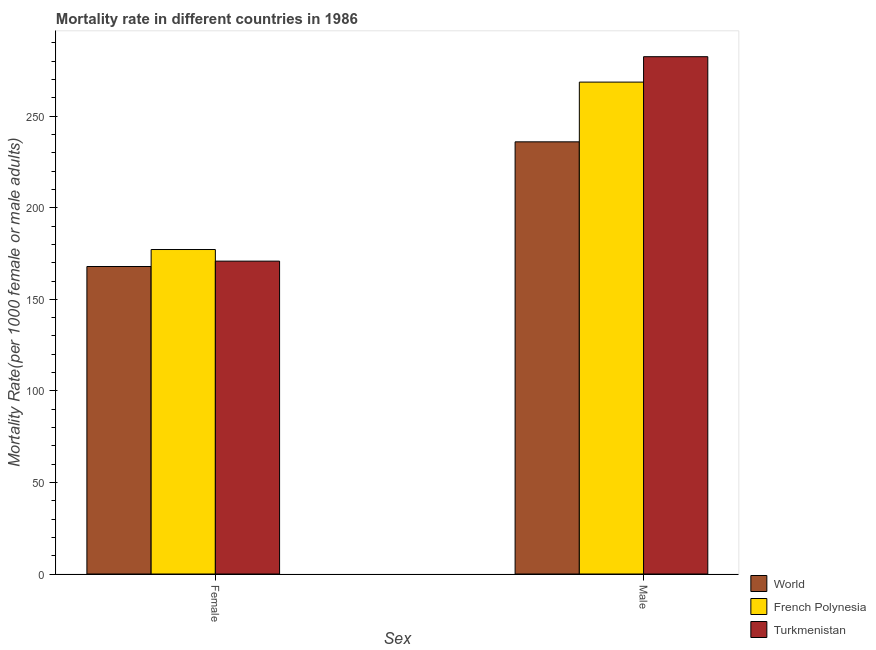How many different coloured bars are there?
Your answer should be compact. 3. How many bars are there on the 1st tick from the right?
Your answer should be very brief. 3. What is the label of the 1st group of bars from the left?
Offer a terse response. Female. What is the female mortality rate in French Polynesia?
Your answer should be compact. 177.19. Across all countries, what is the maximum female mortality rate?
Offer a terse response. 177.19. Across all countries, what is the minimum female mortality rate?
Keep it short and to the point. 167.92. In which country was the male mortality rate maximum?
Make the answer very short. Turkmenistan. What is the total female mortality rate in the graph?
Offer a terse response. 515.96. What is the difference between the female mortality rate in World and that in French Polynesia?
Provide a succinct answer. -9.27. What is the difference between the male mortality rate in World and the female mortality rate in Turkmenistan?
Offer a terse response. 65.14. What is the average male mortality rate per country?
Provide a succinct answer. 262.37. What is the difference between the female mortality rate and male mortality rate in French Polynesia?
Your response must be concise. -91.43. In how many countries, is the female mortality rate greater than 270 ?
Your response must be concise. 0. What is the ratio of the male mortality rate in World to that in Turkmenistan?
Ensure brevity in your answer.  0.84. Is the female mortality rate in World less than that in Turkmenistan?
Your response must be concise. Yes. In how many countries, is the male mortality rate greater than the average male mortality rate taken over all countries?
Keep it short and to the point. 2. What does the 2nd bar from the left in Female represents?
Offer a terse response. French Polynesia. What does the 2nd bar from the right in Male represents?
Provide a short and direct response. French Polynesia. How many bars are there?
Provide a short and direct response. 6. How many countries are there in the graph?
Give a very brief answer. 3. Are the values on the major ticks of Y-axis written in scientific E-notation?
Offer a very short reply. No. Does the graph contain any zero values?
Provide a succinct answer. No. Does the graph contain grids?
Provide a succinct answer. No. Where does the legend appear in the graph?
Your answer should be compact. Bottom right. How many legend labels are there?
Give a very brief answer. 3. How are the legend labels stacked?
Make the answer very short. Vertical. What is the title of the graph?
Offer a very short reply. Mortality rate in different countries in 1986. Does "Barbados" appear as one of the legend labels in the graph?
Your answer should be compact. No. What is the label or title of the X-axis?
Your answer should be very brief. Sex. What is the label or title of the Y-axis?
Ensure brevity in your answer.  Mortality Rate(per 1000 female or male adults). What is the Mortality Rate(per 1000 female or male adults) of World in Female?
Give a very brief answer. 167.92. What is the Mortality Rate(per 1000 female or male adults) in French Polynesia in Female?
Give a very brief answer. 177.19. What is the Mortality Rate(per 1000 female or male adults) of Turkmenistan in Female?
Your answer should be compact. 170.85. What is the Mortality Rate(per 1000 female or male adults) in World in Male?
Ensure brevity in your answer.  236. What is the Mortality Rate(per 1000 female or male adults) of French Polynesia in Male?
Ensure brevity in your answer.  268.62. What is the Mortality Rate(per 1000 female or male adults) in Turkmenistan in Male?
Your answer should be compact. 282.49. Across all Sex, what is the maximum Mortality Rate(per 1000 female or male adults) of World?
Provide a succinct answer. 236. Across all Sex, what is the maximum Mortality Rate(per 1000 female or male adults) of French Polynesia?
Ensure brevity in your answer.  268.62. Across all Sex, what is the maximum Mortality Rate(per 1000 female or male adults) in Turkmenistan?
Give a very brief answer. 282.49. Across all Sex, what is the minimum Mortality Rate(per 1000 female or male adults) in World?
Make the answer very short. 167.92. Across all Sex, what is the minimum Mortality Rate(per 1000 female or male adults) of French Polynesia?
Your response must be concise. 177.19. Across all Sex, what is the minimum Mortality Rate(per 1000 female or male adults) in Turkmenistan?
Provide a short and direct response. 170.85. What is the total Mortality Rate(per 1000 female or male adults) of World in the graph?
Ensure brevity in your answer.  403.91. What is the total Mortality Rate(per 1000 female or male adults) of French Polynesia in the graph?
Your answer should be very brief. 445.8. What is the total Mortality Rate(per 1000 female or male adults) of Turkmenistan in the graph?
Offer a very short reply. 453.34. What is the difference between the Mortality Rate(per 1000 female or male adults) of World in Female and that in Male?
Keep it short and to the point. -68.08. What is the difference between the Mortality Rate(per 1000 female or male adults) of French Polynesia in Female and that in Male?
Provide a succinct answer. -91.43. What is the difference between the Mortality Rate(per 1000 female or male adults) of Turkmenistan in Female and that in Male?
Keep it short and to the point. -111.64. What is the difference between the Mortality Rate(per 1000 female or male adults) of World in Female and the Mortality Rate(per 1000 female or male adults) of French Polynesia in Male?
Your answer should be very brief. -100.7. What is the difference between the Mortality Rate(per 1000 female or male adults) in World in Female and the Mortality Rate(per 1000 female or male adults) in Turkmenistan in Male?
Your answer should be very brief. -114.57. What is the difference between the Mortality Rate(per 1000 female or male adults) of French Polynesia in Female and the Mortality Rate(per 1000 female or male adults) of Turkmenistan in Male?
Your response must be concise. -105.3. What is the average Mortality Rate(per 1000 female or male adults) of World per Sex?
Your response must be concise. 201.96. What is the average Mortality Rate(per 1000 female or male adults) of French Polynesia per Sex?
Make the answer very short. 222.9. What is the average Mortality Rate(per 1000 female or male adults) in Turkmenistan per Sex?
Your answer should be very brief. 226.67. What is the difference between the Mortality Rate(per 1000 female or male adults) of World and Mortality Rate(per 1000 female or male adults) of French Polynesia in Female?
Offer a terse response. -9.27. What is the difference between the Mortality Rate(per 1000 female or male adults) of World and Mortality Rate(per 1000 female or male adults) of Turkmenistan in Female?
Provide a succinct answer. -2.93. What is the difference between the Mortality Rate(per 1000 female or male adults) of French Polynesia and Mortality Rate(per 1000 female or male adults) of Turkmenistan in Female?
Your answer should be compact. 6.34. What is the difference between the Mortality Rate(per 1000 female or male adults) of World and Mortality Rate(per 1000 female or male adults) of French Polynesia in Male?
Give a very brief answer. -32.62. What is the difference between the Mortality Rate(per 1000 female or male adults) in World and Mortality Rate(per 1000 female or male adults) in Turkmenistan in Male?
Make the answer very short. -46.5. What is the difference between the Mortality Rate(per 1000 female or male adults) in French Polynesia and Mortality Rate(per 1000 female or male adults) in Turkmenistan in Male?
Offer a terse response. -13.88. What is the ratio of the Mortality Rate(per 1000 female or male adults) in World in Female to that in Male?
Your response must be concise. 0.71. What is the ratio of the Mortality Rate(per 1000 female or male adults) in French Polynesia in Female to that in Male?
Ensure brevity in your answer.  0.66. What is the ratio of the Mortality Rate(per 1000 female or male adults) of Turkmenistan in Female to that in Male?
Your answer should be compact. 0.6. What is the difference between the highest and the second highest Mortality Rate(per 1000 female or male adults) in World?
Offer a very short reply. 68.08. What is the difference between the highest and the second highest Mortality Rate(per 1000 female or male adults) in French Polynesia?
Make the answer very short. 91.43. What is the difference between the highest and the second highest Mortality Rate(per 1000 female or male adults) in Turkmenistan?
Offer a very short reply. 111.64. What is the difference between the highest and the lowest Mortality Rate(per 1000 female or male adults) of World?
Provide a succinct answer. 68.08. What is the difference between the highest and the lowest Mortality Rate(per 1000 female or male adults) in French Polynesia?
Your answer should be compact. 91.43. What is the difference between the highest and the lowest Mortality Rate(per 1000 female or male adults) in Turkmenistan?
Offer a terse response. 111.64. 